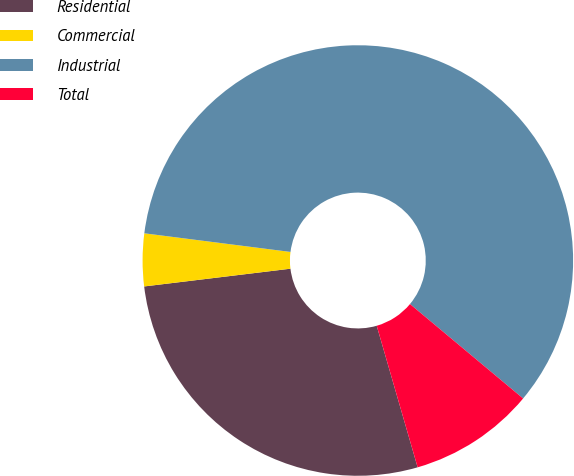<chart> <loc_0><loc_0><loc_500><loc_500><pie_chart><fcel>Residential<fcel>Commercial<fcel>Industrial<fcel>Total<nl><fcel>27.56%<fcel>3.94%<fcel>59.06%<fcel>9.45%<nl></chart> 